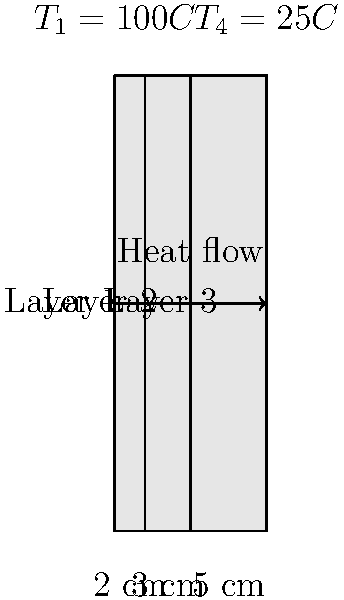A composite wall consists of three layers with different materials and thicknesses as shown in the figure. The temperature on the left side of the wall is 100°C, and on the right side is 25°C. The thermal conductivities of the materials are $k_1 = 0.5 \, W/(m \cdot K)$, $k_2 = 0.8 \, W/(m \cdot K)$, and $k_3 = 0.3 \, W/(m \cdot K)$ for layers 1, 2, and 3 respectively. Calculate the heat transfer rate through the wall per square meter of surface area. To solve this problem, we'll use the concept of thermal resistance in series for a composite wall. Here's the step-by-step solution:

1) The heat transfer rate can be calculated using the formula:
   $$q = \frac{T_1 - T_4}{R_{total}}$$
   where $R_{total}$ is the total thermal resistance of the wall.

2) For a composite wall, the total thermal resistance is the sum of individual layer resistances:
   $$R_{total} = R_1 + R_2 + R_3$$

3) The thermal resistance for each layer is given by:
   $$R = \frac{L}{kA}$$
   where $L$ is the thickness, $k$ is the thermal conductivity, and $A$ is the area (1 m² in this case).

4) Calculate the resistances:
   $$R_1 = \frac{0.02}{0.5 \cdot 1} = 0.04 \, m^2K/W$$
   $$R_2 = \frac{0.03}{0.8 \cdot 1} = 0.0375 \, m^2K/W$$
   $$R_3 = \frac{0.05}{0.3 \cdot 1} = 0.1667 \, m^2K/W$$

5) Sum up the resistances:
   $$R_{total} = 0.04 + 0.0375 + 0.1667 = 0.2442 \, m^2K/W$$

6) Now we can calculate the heat transfer rate:
   $$q = \frac{100°C - 25°C}{0.2442 \, m^2K/W} = 307.13 \, W/m^2$$

Therefore, the heat transfer rate through the wall is approximately 307 W/m².
Answer: 307 W/m² 